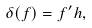<formula> <loc_0><loc_0><loc_500><loc_500>\delta ( f ) = f ^ { \prime } h ,</formula> 